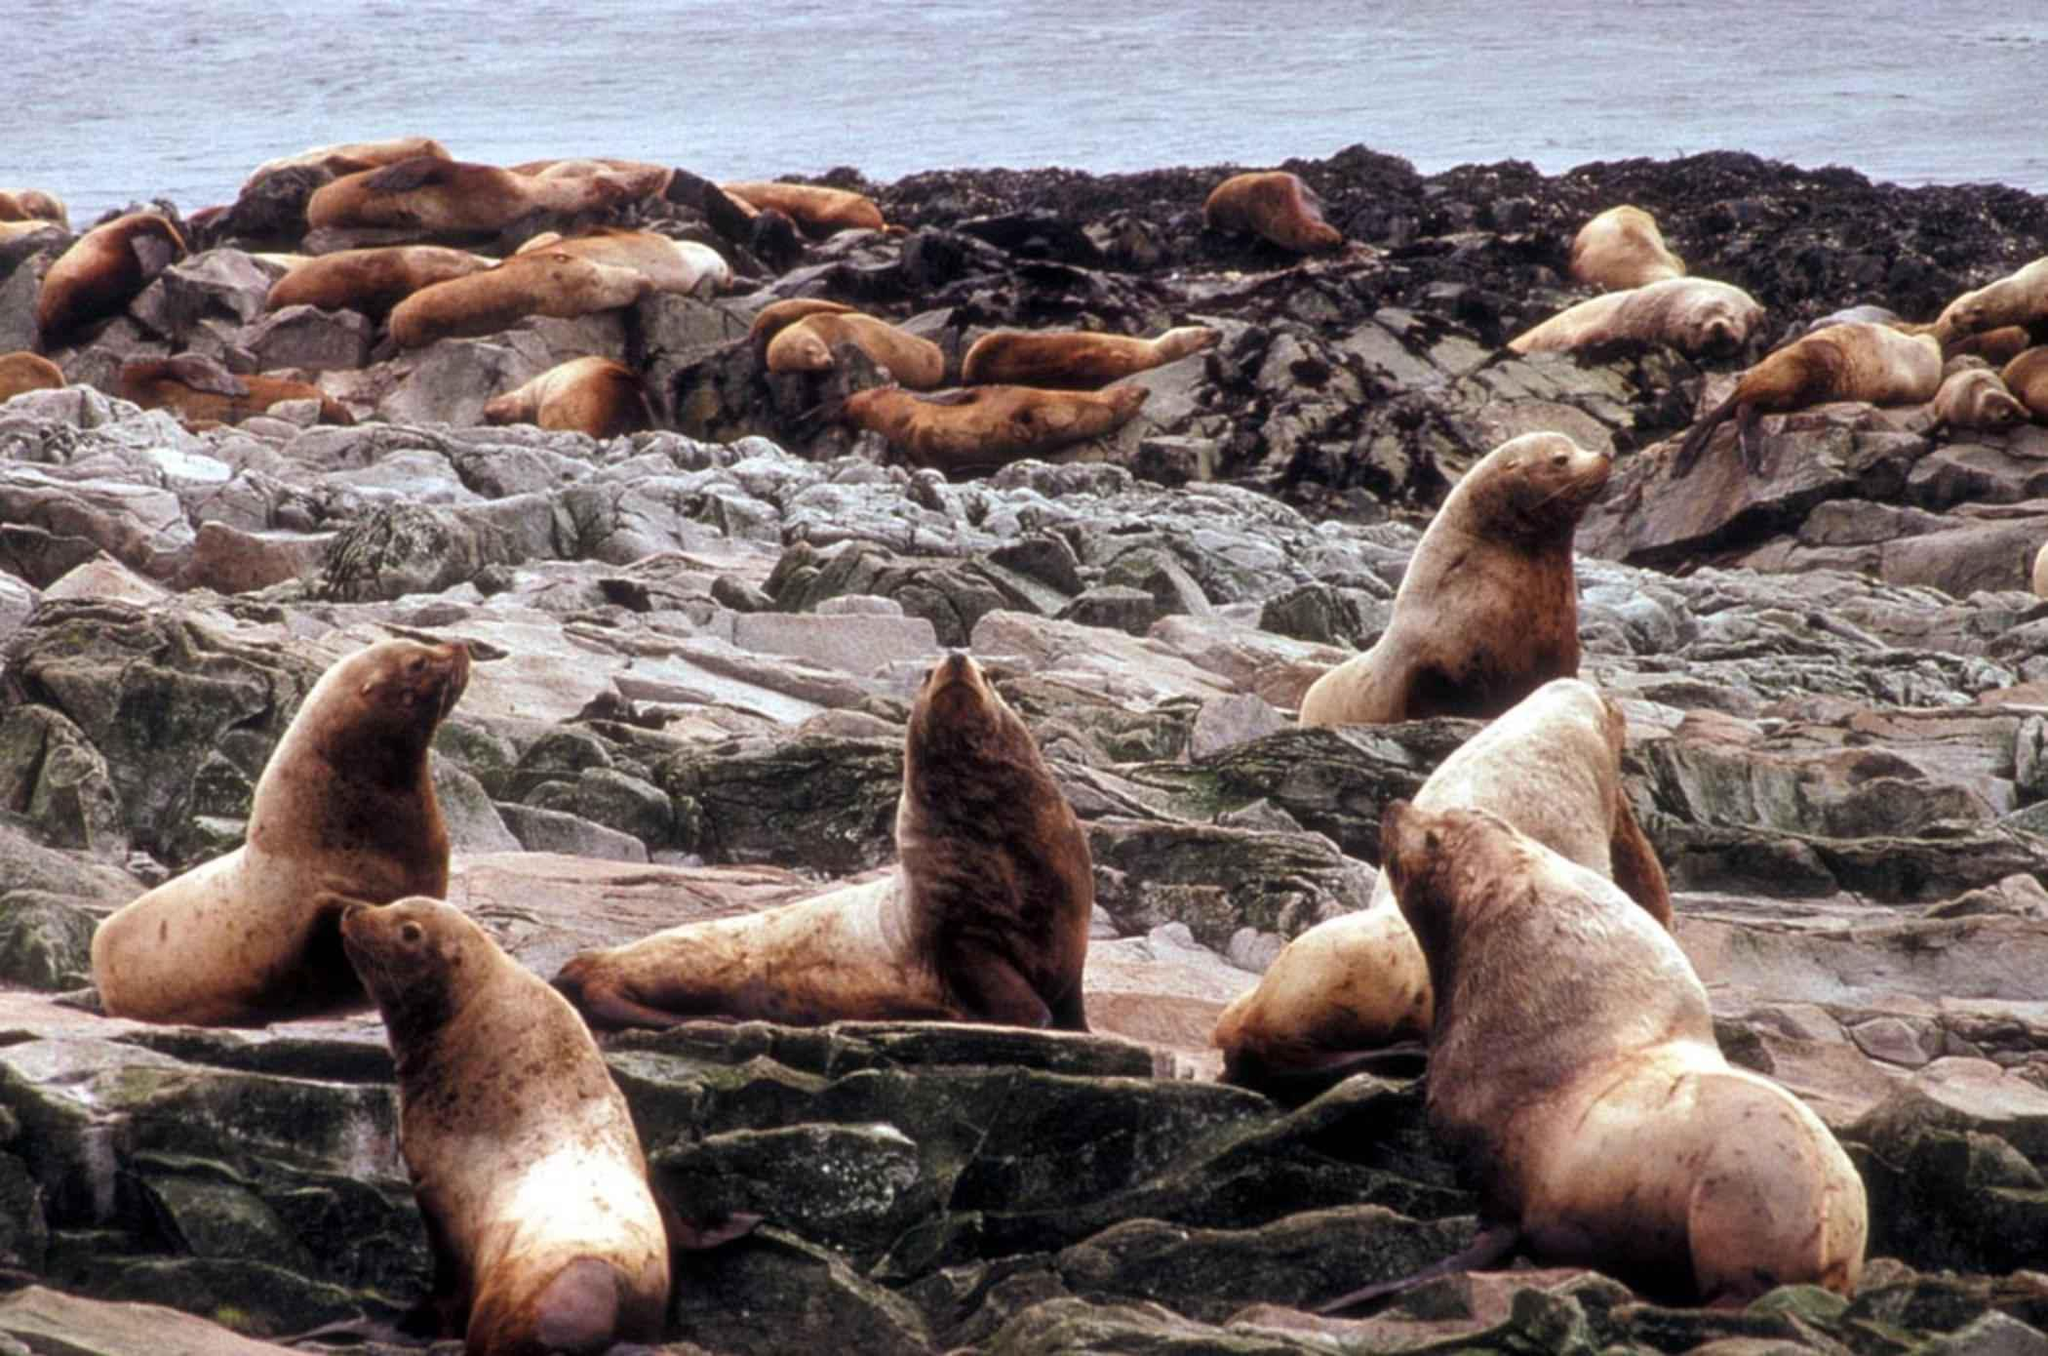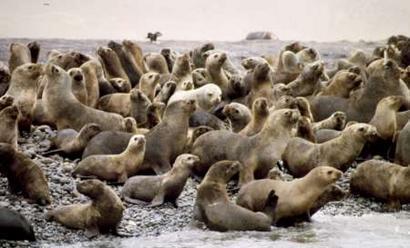The first image is the image on the left, the second image is the image on the right. For the images shown, is this caption "There are at least 5 brown seal in a group with there head head high in at least four directions." true? Answer yes or no. Yes. The first image is the image on the left, the second image is the image on the right. For the images displayed, is the sentence "Seals are in various poses atop large rocks that extend out into the water, with water on both sides, in one image." factually correct? Answer yes or no. No. 